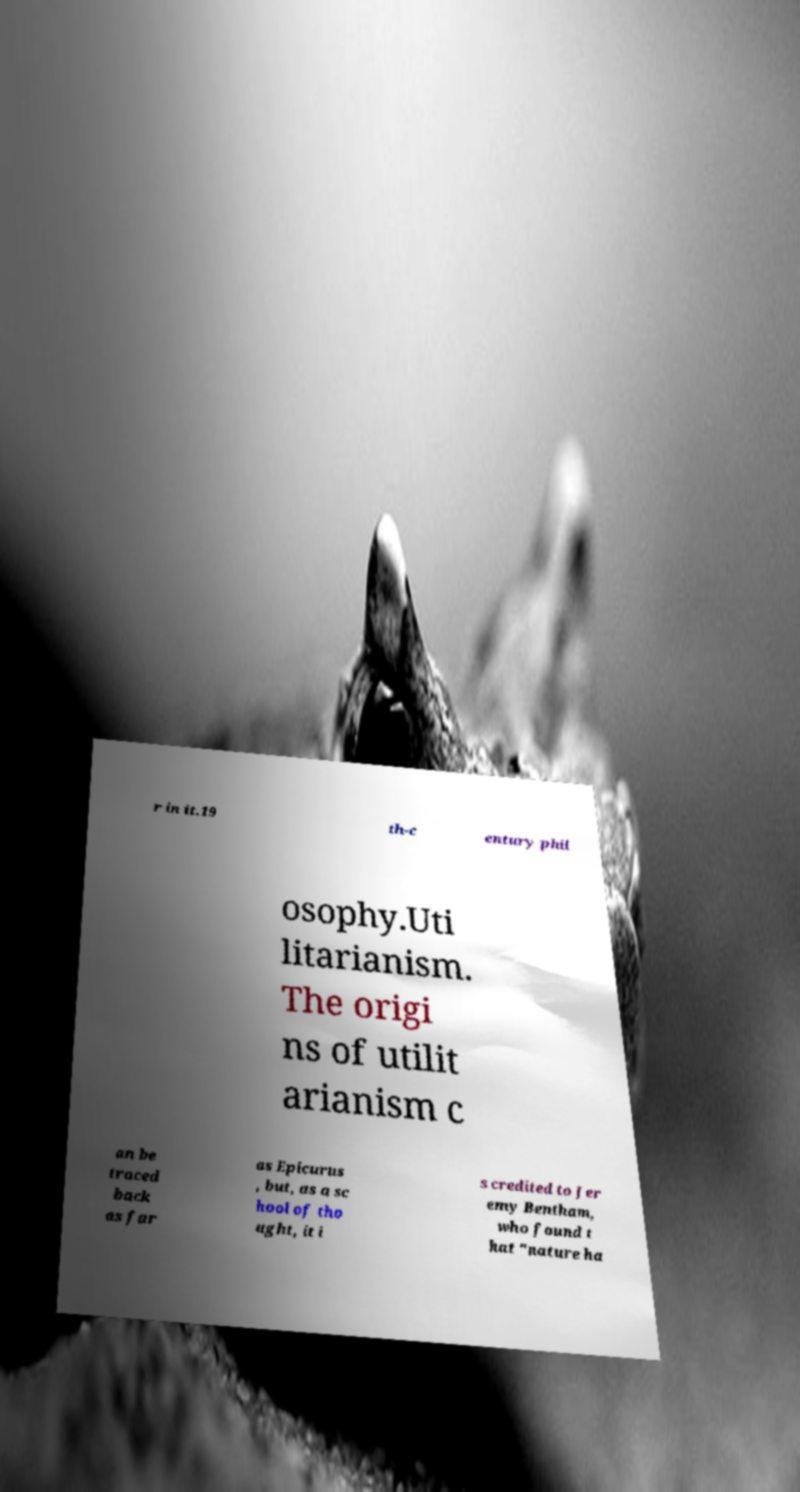Can you accurately transcribe the text from the provided image for me? r in it.19 th-c entury phil osophy.Uti litarianism. The origi ns of utilit arianism c an be traced back as far as Epicurus , but, as a sc hool of tho ught, it i s credited to Jer emy Bentham, who found t hat "nature ha 